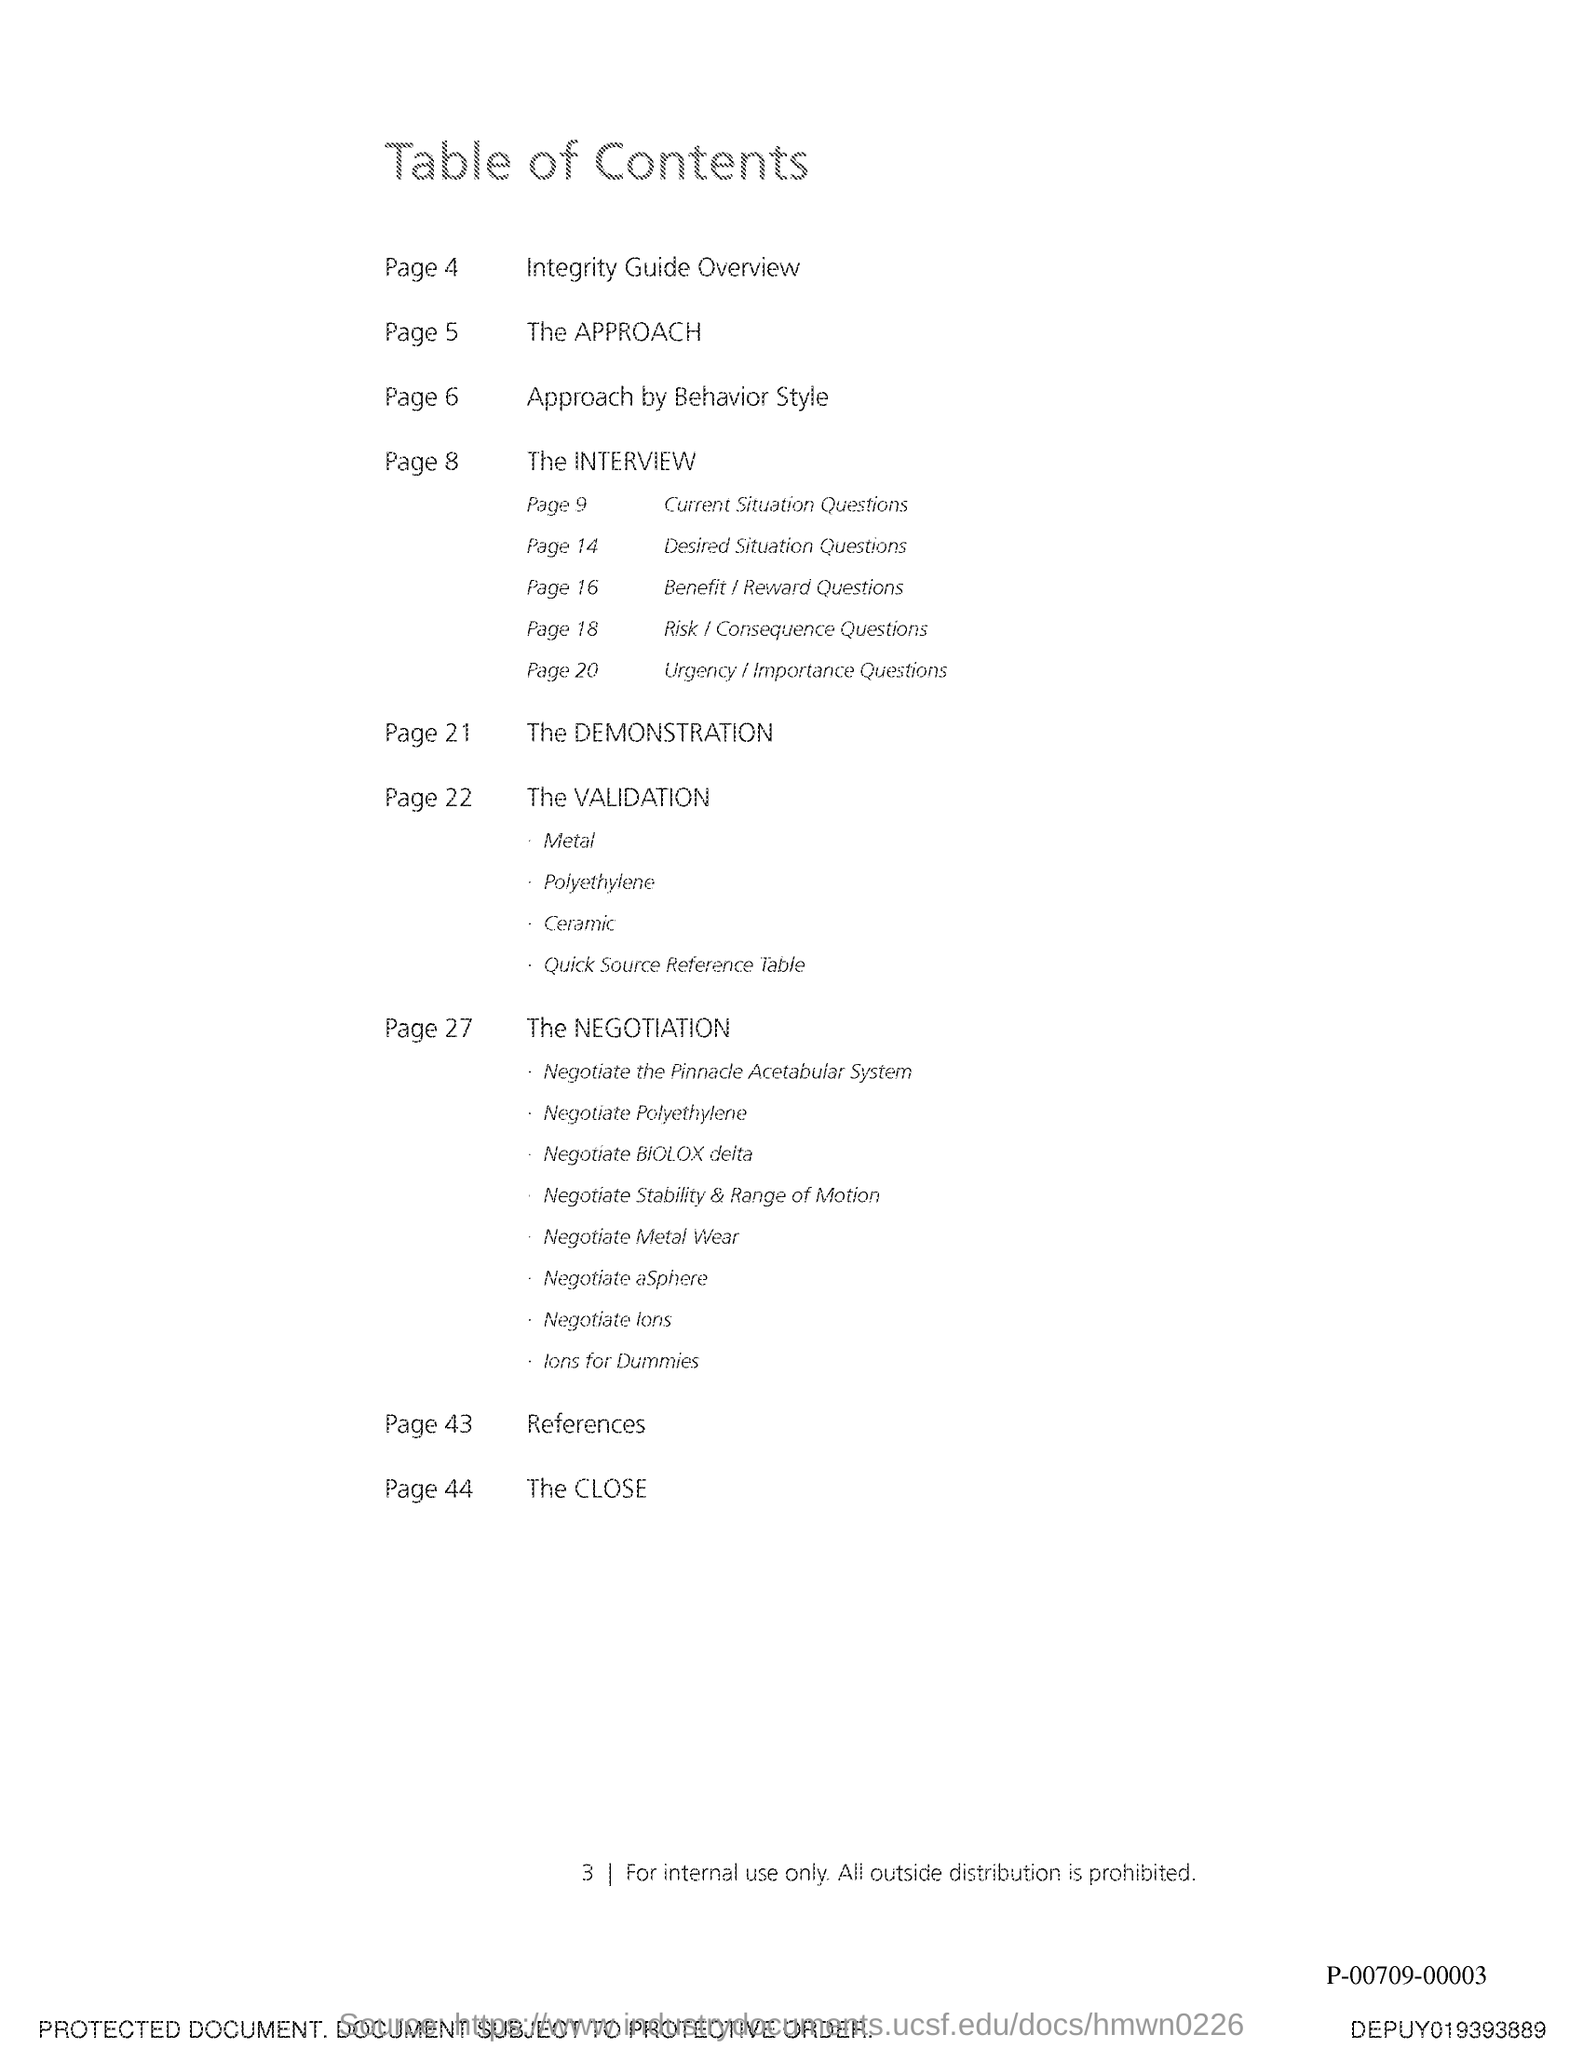Identify some key points in this picture. The validation for the page number 22 is present on the page. The title of the document is [insert title here]. The table of contents is provided for ease of navigation. The reference is on page 43. 